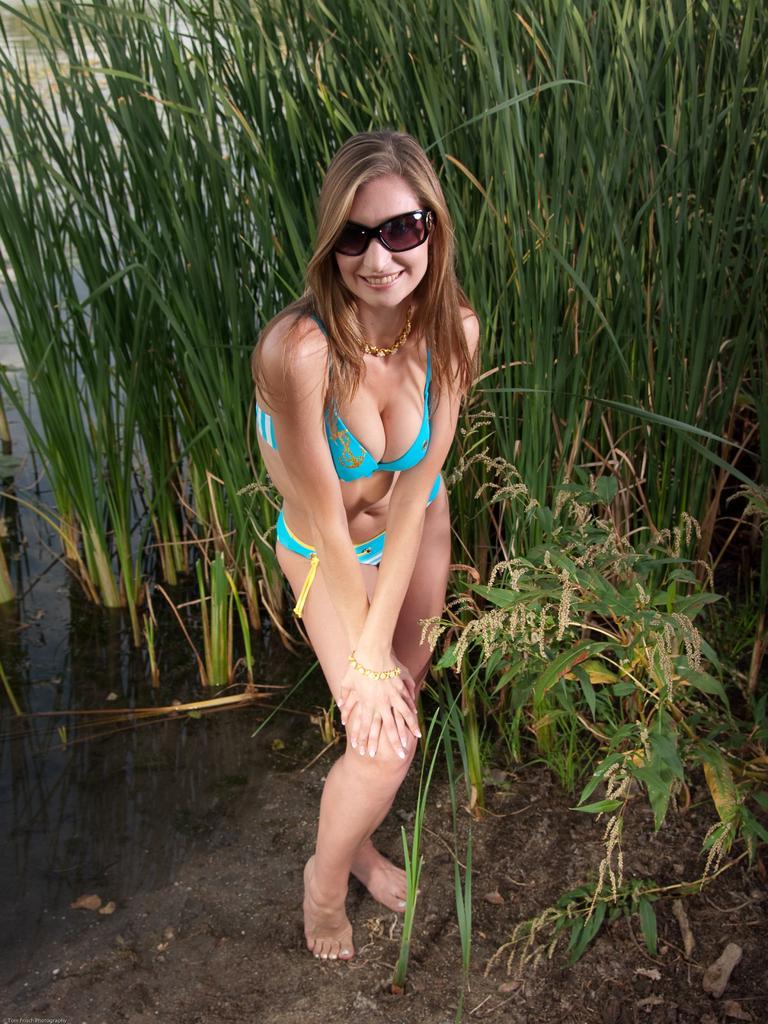Describe this image in one or two sentences. In the picture we can see a woman standing on the mud surface she is with green color bikini and she is smiling and behind her we can see full of grass plants. 